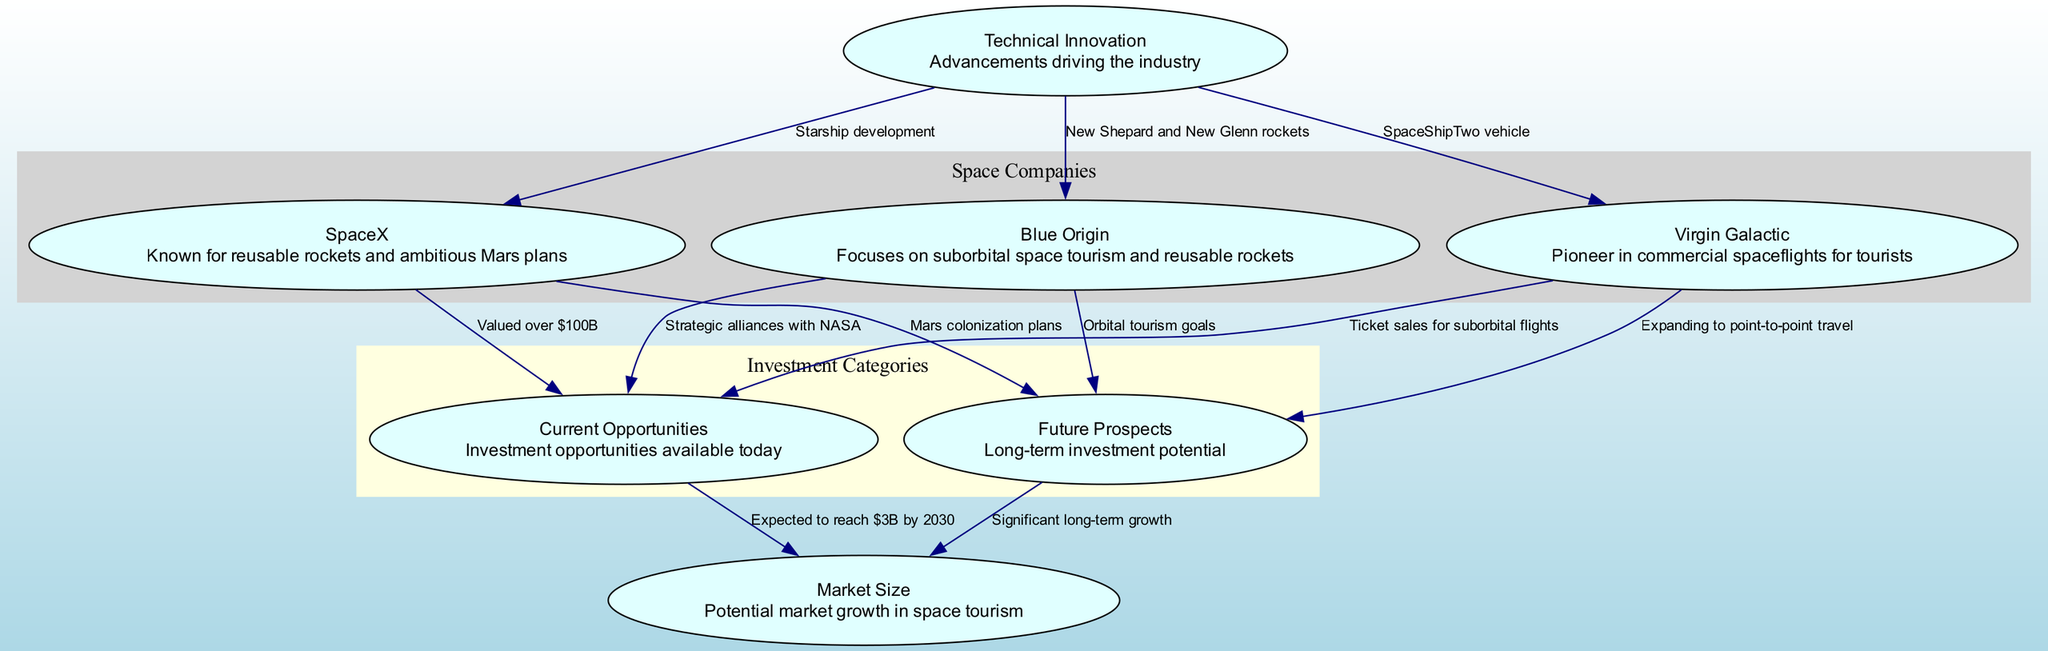What are the three companies represented in the diagram? The diagram features three companies: SpaceX, Blue Origin, and Virgin Galactic. This can be directly identified in the 'Space Companies' cluster, where all three nodes are listed.
Answer: SpaceX, Blue Origin, Virgin Galactic How is SpaceX valued in terms of investment opportunities? The diagram shows that SpaceX is valued over $100B in the 'Current Opportunities' node. This connection is highlighted with an edge leading from SpaceX to Current Opportunities labeled with this value.
Answer: Valued over $100B What sphere does Blue Origin focus on according to the diagram? The edge from Blue Origin to Current Opportunities states that it has strategic alliances with NASA, indicating a focus on suborbital space tourism. This shows its primary investment area in the current market.
Answer: Suborbital space tourism What future goal is associated with Virgin Galactic? Virgin Galactic's node connects to Future Prospects, indicating its expansion plans. The edge connecting these two shows that their future goal is to expand to point-to-point travel, as indicated by the label.
Answer: Expanding to point-to-point travel What is the expected market size for space tourism by 2030? The edge from Current Opportunities to Market Size suggests that the expected market size is to reach $3B by 2030. This figures prominently in the diagram under the relevant investment category.
Answer: $3B by 2030 What role does technical innovation play according to the diagram? Technical Innovation is linked to all three companies with specific advancements highlighted for each. For example, SpaceX's Starship development, Blue Origin's New Shepard and New Glenn rockets, and Virgin Galactic's SpaceShipTwo vehicle demonstrate how tech innovation drives investments in these companies.
Answer: Advancements driving the industry Which company has future plans related to Mars? The edge from SpaceX to Future Prospects indicates that SpaceX has Mars colonization plans, setting it apart in future growth potential. This is explicitly mentioned on the connected edge.
Answer: Mars colonization plans What category does the edge from Future Prospects to Market Size fall under? The edge from Future Prospects to Market Size indicates that this connection shows significant long-term growth, and this depicts how current future investments are linked to potential market expansion.
Answer: Significant long-term growth 